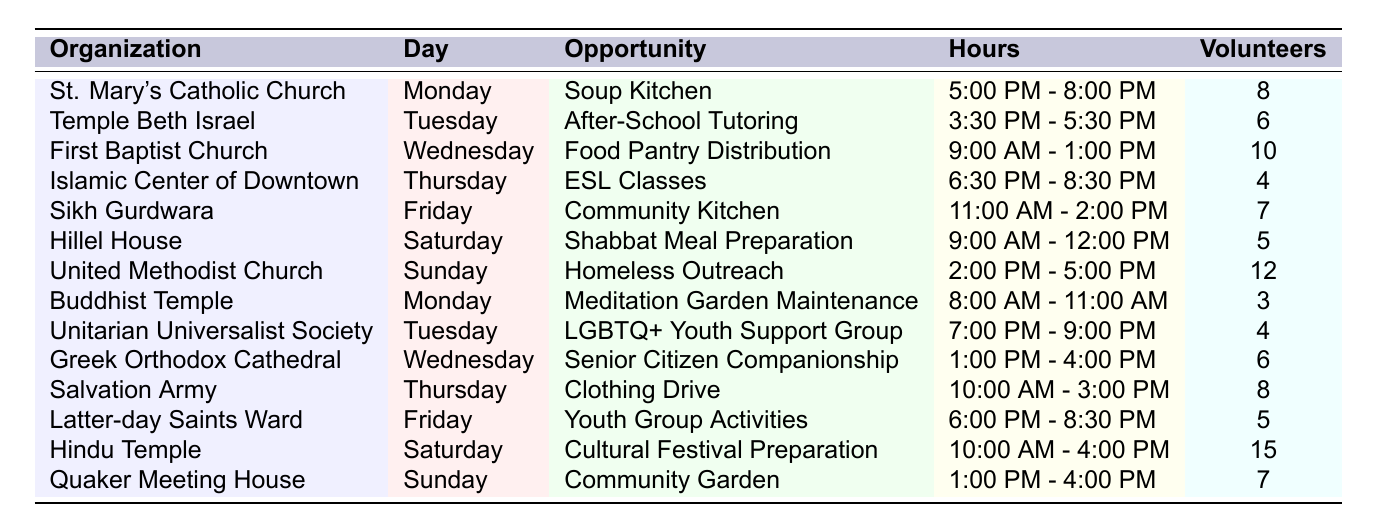What volunteer opportunity is available on Monday at St. Mary's Catholic Church? The table lists "Soup Kitchen" as the volunteer opportunity for St. Mary's Catholic Church on Monday.
Answer: Soup Kitchen How many volunteers are needed for the ESL Classes at the Islamic Center of Downtown on Thursday? The table indicates that 4 volunteers are needed for the ESL Classes on Thursday at the Islamic Center of Downtown.
Answer: 4 Which organization offers food distribution services on Wednesday and how many volunteers are needed? The First Baptist Church offers "Food Pantry Distribution" on Wednesday, requiring 10 volunteers as per the table.
Answer: First Baptist Church, 10 volunteers Is there a volunteer opportunity on Friday that requires more than 7 volunteers? The table shows that the Hindu Temple on Saturday requires 15 volunteers for "Cultural Festival Preparation," which is on Saturday, not Friday. Therefore, the answer is no.
Answer: No What is the total number of volunteers needed on Sundays for both the United Methodist Church and Quaker Meeting House? The United Methodist Church needs 12 volunteers and the Quaker Meeting House needs 7 volunteers. Adding these gives 12 + 7 = 19 volunteers needed on Sundays in total.
Answer: 19 On which day do the least number of volunteers (in total) work and what is the opportunity? The least number of volunteers needed is 3 for "Meditation Garden Maintenance" at the Buddhist Temple on Monday.
Answer: Monday, Meditation Garden Maintenance, 3 volunteers How many total volunteer opportunities are there across all the organizations listed in the table? There are 14 organizations listed in the table, each providing a unique volunteering opportunity. Thus, there are 14 total volunteer opportunities.
Answer: 14 What organization has the most volunteers needed for a single opportunity and how many volunteers are needed? The Hindu Temple needs the most volunteers, requiring 15 for the "Cultural Festival Preparation" on Saturday.
Answer: Hindu Temple, 15 volunteers Are there any volunteer opportunities that occur in the early morning hours? Yes, there is "Meditation Garden Maintenance" at the Buddhist Temple, which takes place from 8:00 AM to 11:00 AM on Monday.
Answer: Yes Which day has the most volunteer opportunities listed and what are they? Each day has one opportunity listed; therefore, no day has more than one opportunity. All days have equal opportunities.
Answer: All days have one opportunity each 